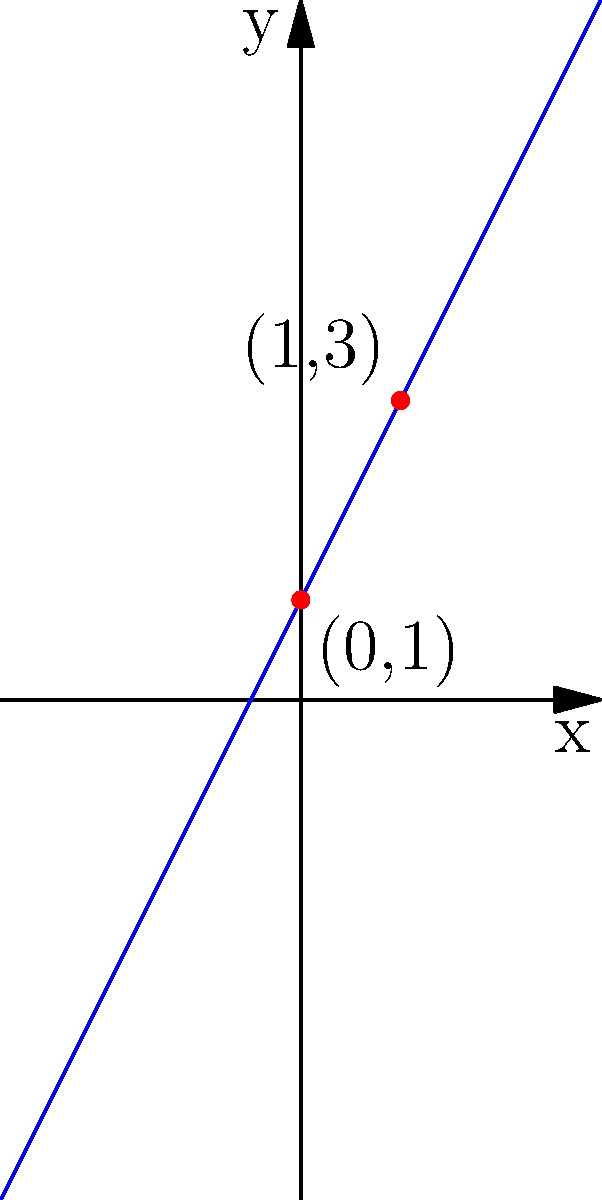Look at the graph of the linear equation. Can you identify the slope and y-intercept of this line? Write your answer in the form (slope, y-intercept). Let's break this down step-by-step:

1. To find the slope, we need two points on the line. We can see two red dots on the line:
   (0,1) and (1,3)

2. The slope formula is:
   $m = \frac{y_2 - y_1}{x_2 - x_1}$

3. Plugging in our points:
   $m = \frac{3 - 1}{1 - 0} = \frac{2}{1} = 2$

4. The y-intercept is where the line crosses the y-axis. We can see that it crosses at (0,1).

5. Therefore, the y-intercept is 1.

6. The equation of this line is in the form $y = mx + b$, where $m$ is the slope and $b$ is the y-intercept.
   So, the equation is $y = 2x + 1$

Therefore, the slope is 2 and the y-intercept is 1.
Answer: (2, 1) 